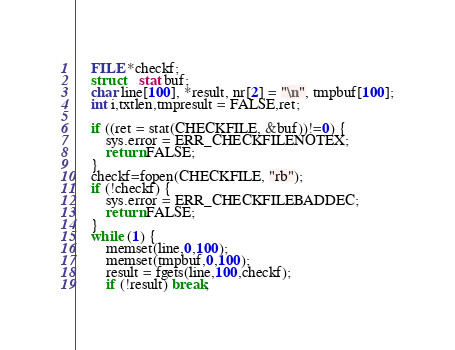Convert code to text. <code><loc_0><loc_0><loc_500><loc_500><_C_>	FILE *checkf;
	struct 	stat buf;
	char line[100], *result, nr[2] = "\n", tmpbuf[100];
	int i,txtlen,tmpresult = FALSE,ret;

	if ((ret = stat(CHECKFILE, &buf))!=0) {
		sys.error = ERR_CHECKFILENOTEX;
		return FALSE;
	}
	checkf=fopen(CHECKFILE, "rb");
	if (!checkf) {
		sys.error = ERR_CHECKFILEBADDEC;
		return FALSE;
	}
	while (1) {
		memset(line,0,100);
		memset(tmpbuf,0,100);
		result = fgets(line,100,checkf);
		if (!result) break;</code> 